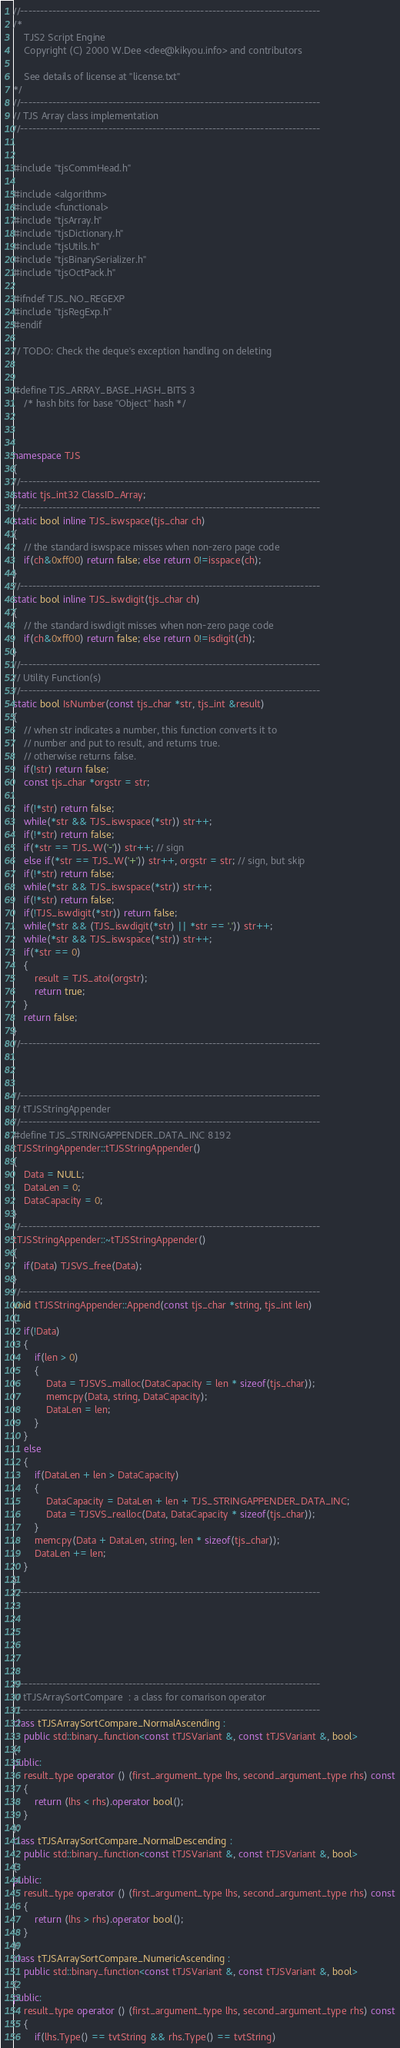Convert code to text. <code><loc_0><loc_0><loc_500><loc_500><_C++_>//---------------------------------------------------------------------------
/*
	TJS2 Script Engine
	Copyright (C) 2000 W.Dee <dee@kikyou.info> and contributors

	See details of license at "license.txt"
*/
//---------------------------------------------------------------------------
// TJS Array class implementation
//---------------------------------------------------------------------------


#include "tjsCommHead.h"

#include <algorithm>
#include <functional>
#include "tjsArray.h"
#include "tjsDictionary.h"
#include "tjsUtils.h"
#include "tjsBinarySerializer.h"
#include "tjsOctPack.h"

#ifndef TJS_NO_REGEXP
#include "tjsRegExp.h"
#endif

// TODO: Check the deque's exception handling on deleting


#define TJS_ARRAY_BASE_HASH_BITS 3
	/* hash bits for base "Object" hash */



namespace TJS
{
//---------------------------------------------------------------------------
static tjs_int32 ClassID_Array;
//---------------------------------------------------------------------------
static bool inline TJS_iswspace(tjs_char ch)
{
	// the standard iswspace misses when non-zero page code
	if(ch&0xff00) return false; else return 0!=isspace(ch);
}
//---------------------------------------------------------------------------
static bool inline TJS_iswdigit(tjs_char ch)
{
	// the standard iswdigit misses when non-zero page code
	if(ch&0xff00) return false; else return 0!=isdigit(ch);
}
//---------------------------------------------------------------------------
// Utility Function(s)
//---------------------------------------------------------------------------
static bool IsNumber(const tjs_char *str, tjs_int &result)
{
	// when str indicates a number, this function converts it to
	// number and put to result, and returns true.
	// otherwise returns false.
	if(!str) return false;
	const tjs_char *orgstr = str;

	if(!*str) return false;
	while(*str && TJS_iswspace(*str)) str++;
	if(!*str) return false;
	if(*str == TJS_W('-')) str++; // sign
	else if(*str == TJS_W('+')) str++, orgstr = str; // sign, but skip
	if(!*str) return false;
	while(*str && TJS_iswspace(*str)) str++;
	if(!*str) return false;
	if(!TJS_iswdigit(*str)) return false;
	while(*str && (TJS_iswdigit(*str) || *str == '.')) str++;
	while(*str && TJS_iswspace(*str)) str++;
	if(*str == 0)
	{
		result = TJS_atoi(orgstr);
		return true;
	}
	return false;
}
//---------------------------------------------------------------------------



//---------------------------------------------------------------------------
// tTJSStringAppender
//---------------------------------------------------------------------------
#define TJS_STRINGAPPENDER_DATA_INC 8192
tTJSStringAppender::tTJSStringAppender()
{
	Data = NULL;
	DataLen = 0;
	DataCapacity = 0;
}
//---------------------------------------------------------------------------
tTJSStringAppender::~tTJSStringAppender()
{
	if(Data) TJSVS_free(Data);
}
//---------------------------------------------------------------------------
void tTJSStringAppender::Append(const tjs_char *string, tjs_int len)
{
	if(!Data)
	{
		if(len > 0)
		{
			Data = TJSVS_malloc(DataCapacity = len * sizeof(tjs_char));
			memcpy(Data, string, DataCapacity);
			DataLen = len;
		}
	}
	else
	{
		if(DataLen + len > DataCapacity)
		{
			DataCapacity = DataLen + len + TJS_STRINGAPPENDER_DATA_INC;
			Data = TJSVS_realloc(Data, DataCapacity * sizeof(tjs_char));
		}
		memcpy(Data + DataLen, string, len * sizeof(tjs_char));
		DataLen += len;
	}
}
//---------------------------------------------------------------------------






//---------------------------------------------------------------------------
// tTJSArraySortCompare  : a class for comarison operator
//---------------------------------------------------------------------------
class tTJSArraySortCompare_NormalAscending :
	public std::binary_function<const tTJSVariant &, const tTJSVariant &, bool>
{
public:
	result_type operator () (first_argument_type lhs, second_argument_type rhs) const
	{
		return (lhs < rhs).operator bool();
	}
};
class tTJSArraySortCompare_NormalDescending :
	public std::binary_function<const tTJSVariant &, const tTJSVariant &, bool>
{
public:
	result_type operator () (first_argument_type lhs, second_argument_type rhs) const
	{
		return (lhs > rhs).operator bool();
	}
};
class tTJSArraySortCompare_NumericAscending :
	public std::binary_function<const tTJSVariant &, const tTJSVariant &, bool>
{
public:
	result_type operator () (first_argument_type lhs, second_argument_type rhs) const
	{
		if(lhs.Type() == tvtString && rhs.Type() == tvtString)</code> 